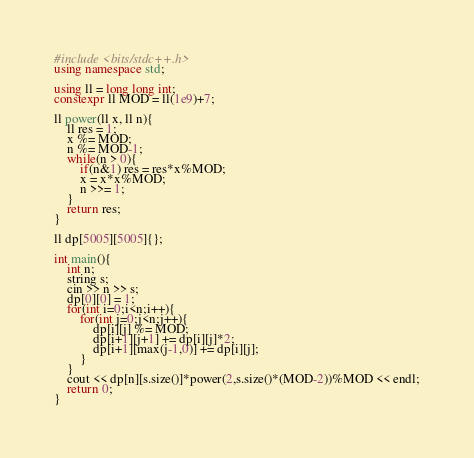<code> <loc_0><loc_0><loc_500><loc_500><_C++_>#include <bits/stdc++.h>
using namespace std;

using ll = long long int;
constexpr ll MOD = ll(1e9)+7;

ll power(ll x, ll n){
    ll res = 1;
    x %= MOD;
    n %= MOD-1;
    while(n > 0){
        if(n&1) res = res*x%MOD;
        x = x*x%MOD;
        n >>= 1;
    }
    return res;
}

ll dp[5005][5005]{};

int main(){
    int n;
    string s;
    cin >> n >> s;
    dp[0][0] = 1;
    for(int i=0;i<n;i++){
        for(int j=0;j<n;j++){
            dp[i][j] %= MOD;
            dp[i+1][j+1] += dp[i][j]*2;
            dp[i+1][max(j-1,0)] += dp[i][j];
        }
    }
    cout << dp[n][s.size()]*power(2,s.size()*(MOD-2))%MOD << endl;
    return 0;
}
</code> 